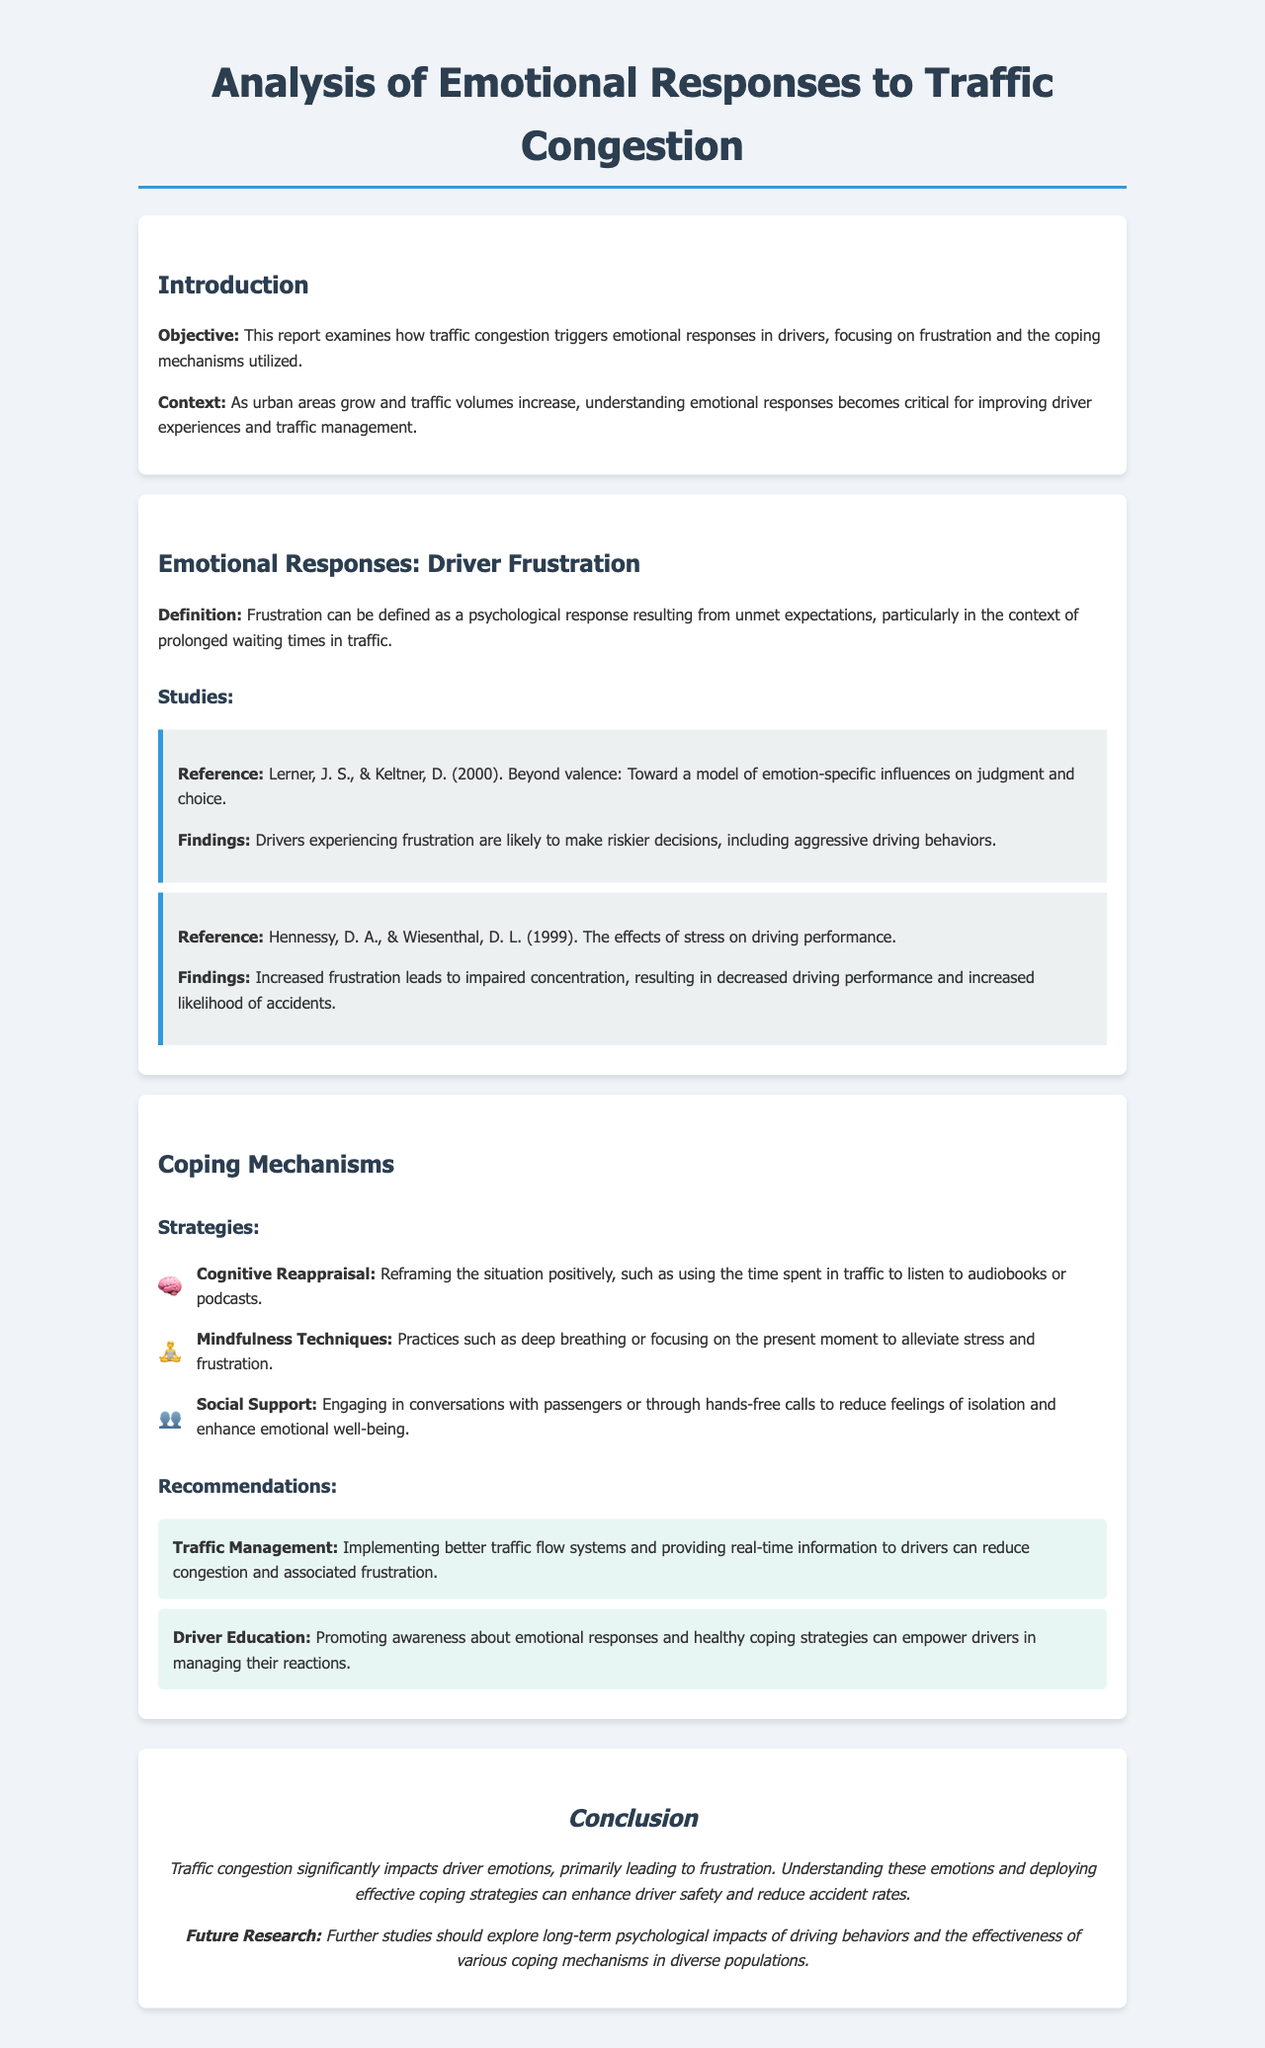What is the main objective of the report? The objective is to examine how traffic congestion triggers emotional responses in drivers, focusing on frustration and coping mechanisms.
Answer: To examine how traffic congestion triggers emotional responses in drivers, focusing on frustration and coping mechanisms Who are the authors of the study referenced regarding judgment and choice? The study referenced is by Lerner and Keltner from the year 2000.
Answer: Lerner, J. S., & Keltner, D What psychological response defines frustration in the context of this report? Frustration is defined as a psychological response resulting from unmet expectations, particularly in the context of prolonged waiting times in traffic.
Answer: A psychological response resulting from unmet expectations What coping strategy involves listening to audiobooks? The coping strategy that involves listening to audiobooks is Cognitive Reappraisal.
Answer: Cognitive Reappraisal According to the findings, what risky behavior are drivers likely to engage in when experiencing frustration? The findings suggest that drivers experiencing frustration are likely to make riskier decisions, including aggressive driving behaviors.
Answer: Aggressive driving behaviors What mindfulness technique is mentioned as alleviating stress? Deep breathing is mentioned as a mindfulness technique to alleviate stress and frustration.
Answer: Deep breathing What recommendation is given for improving traffic management? The recommendation for improving traffic management is implementing better traffic flow systems and providing real-time information to drivers.
Answer: Implementing better traffic flow systems What emotional impact does traffic congestion have on drivers as per the conclusion? Traffic congestion significantly impacts driver emotions primarily leading to frustration.
Answer: Frustration What should future research explore according to the conclusion? Future research should explore long-term psychological impacts of driving behaviors and the effectiveness of various coping mechanisms in diverse populations.
Answer: Long-term psychological impacts 